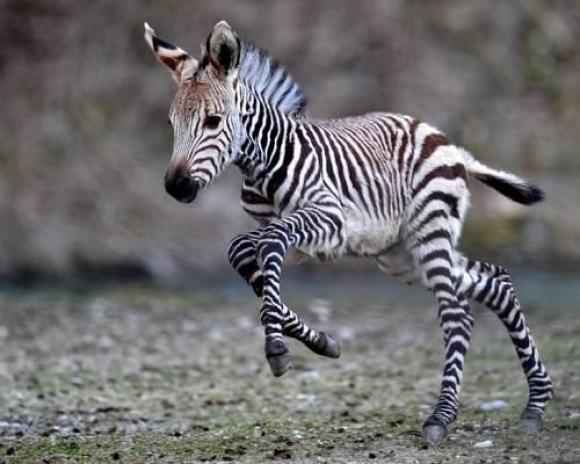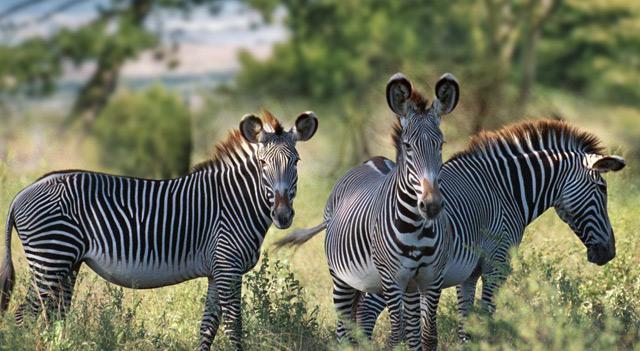The first image is the image on the left, the second image is the image on the right. Given the left and right images, does the statement "One image shows two zebra standing in profile turned toward one another, each one with its head over the back of the other." hold true? Answer yes or no. No. The first image is the image on the left, the second image is the image on the right. Considering the images on both sides, is "The left image contains no more than one zebra." valid? Answer yes or no. Yes. 